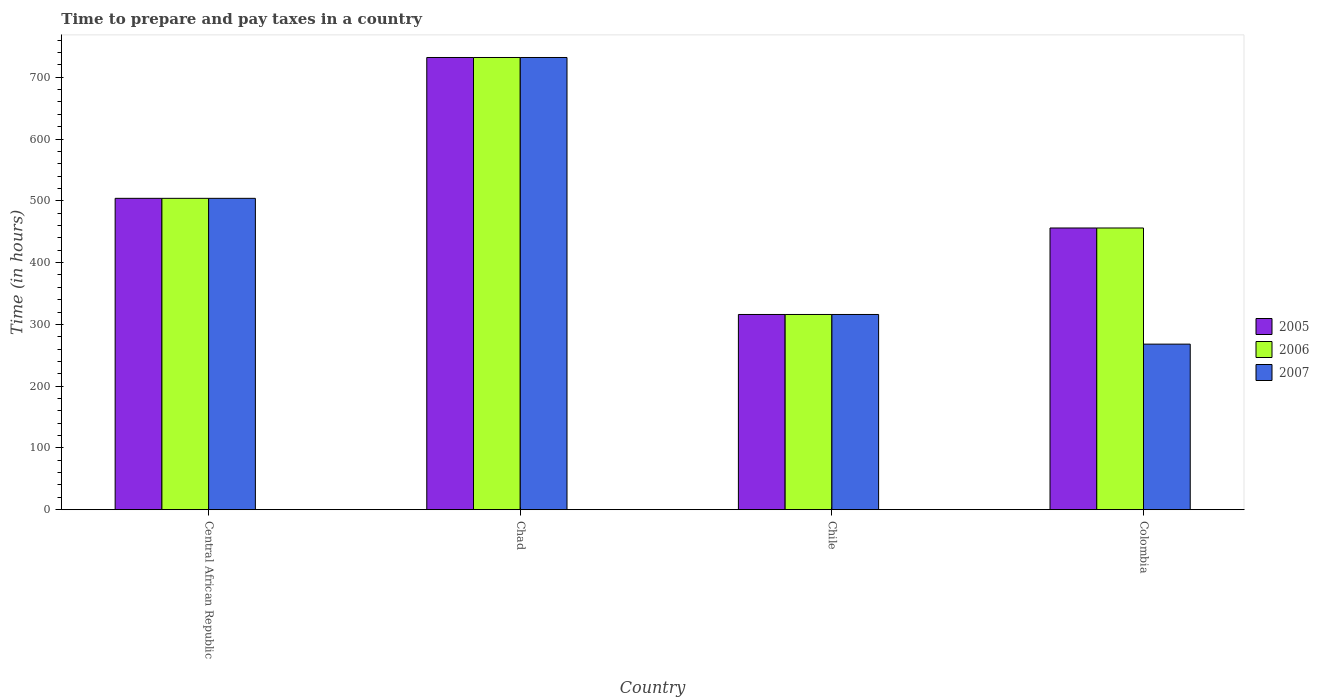How many bars are there on the 1st tick from the left?
Ensure brevity in your answer.  3. What is the label of the 1st group of bars from the left?
Your answer should be very brief. Central African Republic. What is the number of hours required to prepare and pay taxes in 2005 in Chad?
Provide a short and direct response. 732. Across all countries, what is the maximum number of hours required to prepare and pay taxes in 2006?
Your response must be concise. 732. Across all countries, what is the minimum number of hours required to prepare and pay taxes in 2005?
Offer a very short reply. 316. In which country was the number of hours required to prepare and pay taxes in 2005 maximum?
Your answer should be compact. Chad. In which country was the number of hours required to prepare and pay taxes in 2007 minimum?
Offer a terse response. Colombia. What is the total number of hours required to prepare and pay taxes in 2007 in the graph?
Keep it short and to the point. 1820. What is the difference between the number of hours required to prepare and pay taxes in 2006 in Central African Republic and that in Chad?
Keep it short and to the point. -228. What is the difference between the number of hours required to prepare and pay taxes in 2006 in Chile and the number of hours required to prepare and pay taxes in 2005 in Central African Republic?
Keep it short and to the point. -188. What is the average number of hours required to prepare and pay taxes in 2005 per country?
Keep it short and to the point. 502. What is the difference between the number of hours required to prepare and pay taxes of/in 2006 and number of hours required to prepare and pay taxes of/in 2007 in Central African Republic?
Your answer should be compact. 0. What is the ratio of the number of hours required to prepare and pay taxes in 2006 in Chad to that in Colombia?
Your answer should be compact. 1.61. Is the number of hours required to prepare and pay taxes in 2005 in Chile less than that in Colombia?
Ensure brevity in your answer.  Yes. What is the difference between the highest and the second highest number of hours required to prepare and pay taxes in 2007?
Your answer should be very brief. -228. What is the difference between the highest and the lowest number of hours required to prepare and pay taxes in 2005?
Make the answer very short. 416. Is the sum of the number of hours required to prepare and pay taxes in 2006 in Central African Republic and Chile greater than the maximum number of hours required to prepare and pay taxes in 2007 across all countries?
Your response must be concise. Yes. What does the 3rd bar from the left in Chad represents?
Your response must be concise. 2007. How many bars are there?
Ensure brevity in your answer.  12. Does the graph contain any zero values?
Offer a terse response. No. Does the graph contain grids?
Offer a terse response. No. How many legend labels are there?
Give a very brief answer. 3. How are the legend labels stacked?
Provide a succinct answer. Vertical. What is the title of the graph?
Your answer should be compact. Time to prepare and pay taxes in a country. What is the label or title of the X-axis?
Offer a terse response. Country. What is the label or title of the Y-axis?
Keep it short and to the point. Time (in hours). What is the Time (in hours) in 2005 in Central African Republic?
Keep it short and to the point. 504. What is the Time (in hours) of 2006 in Central African Republic?
Keep it short and to the point. 504. What is the Time (in hours) in 2007 in Central African Republic?
Your response must be concise. 504. What is the Time (in hours) of 2005 in Chad?
Your answer should be very brief. 732. What is the Time (in hours) of 2006 in Chad?
Your answer should be very brief. 732. What is the Time (in hours) in 2007 in Chad?
Your answer should be compact. 732. What is the Time (in hours) of 2005 in Chile?
Keep it short and to the point. 316. What is the Time (in hours) in 2006 in Chile?
Your answer should be very brief. 316. What is the Time (in hours) of 2007 in Chile?
Keep it short and to the point. 316. What is the Time (in hours) of 2005 in Colombia?
Keep it short and to the point. 456. What is the Time (in hours) in 2006 in Colombia?
Your answer should be compact. 456. What is the Time (in hours) in 2007 in Colombia?
Provide a succinct answer. 268. Across all countries, what is the maximum Time (in hours) of 2005?
Your answer should be compact. 732. Across all countries, what is the maximum Time (in hours) of 2006?
Your answer should be very brief. 732. Across all countries, what is the maximum Time (in hours) of 2007?
Your answer should be very brief. 732. Across all countries, what is the minimum Time (in hours) in 2005?
Keep it short and to the point. 316. Across all countries, what is the minimum Time (in hours) of 2006?
Keep it short and to the point. 316. Across all countries, what is the minimum Time (in hours) in 2007?
Provide a short and direct response. 268. What is the total Time (in hours) of 2005 in the graph?
Ensure brevity in your answer.  2008. What is the total Time (in hours) in 2006 in the graph?
Offer a terse response. 2008. What is the total Time (in hours) in 2007 in the graph?
Your answer should be very brief. 1820. What is the difference between the Time (in hours) of 2005 in Central African Republic and that in Chad?
Offer a very short reply. -228. What is the difference between the Time (in hours) in 2006 in Central African Republic and that in Chad?
Keep it short and to the point. -228. What is the difference between the Time (in hours) in 2007 in Central African Republic and that in Chad?
Your answer should be very brief. -228. What is the difference between the Time (in hours) of 2005 in Central African Republic and that in Chile?
Your answer should be very brief. 188. What is the difference between the Time (in hours) of 2006 in Central African Republic and that in Chile?
Offer a very short reply. 188. What is the difference between the Time (in hours) in 2007 in Central African Republic and that in Chile?
Give a very brief answer. 188. What is the difference between the Time (in hours) of 2005 in Central African Republic and that in Colombia?
Ensure brevity in your answer.  48. What is the difference between the Time (in hours) in 2006 in Central African Republic and that in Colombia?
Keep it short and to the point. 48. What is the difference between the Time (in hours) of 2007 in Central African Republic and that in Colombia?
Make the answer very short. 236. What is the difference between the Time (in hours) of 2005 in Chad and that in Chile?
Make the answer very short. 416. What is the difference between the Time (in hours) in 2006 in Chad and that in Chile?
Keep it short and to the point. 416. What is the difference between the Time (in hours) in 2007 in Chad and that in Chile?
Your answer should be compact. 416. What is the difference between the Time (in hours) in 2005 in Chad and that in Colombia?
Keep it short and to the point. 276. What is the difference between the Time (in hours) in 2006 in Chad and that in Colombia?
Offer a terse response. 276. What is the difference between the Time (in hours) in 2007 in Chad and that in Colombia?
Keep it short and to the point. 464. What is the difference between the Time (in hours) of 2005 in Chile and that in Colombia?
Make the answer very short. -140. What is the difference between the Time (in hours) of 2006 in Chile and that in Colombia?
Provide a short and direct response. -140. What is the difference between the Time (in hours) in 2005 in Central African Republic and the Time (in hours) in 2006 in Chad?
Your answer should be compact. -228. What is the difference between the Time (in hours) of 2005 in Central African Republic and the Time (in hours) of 2007 in Chad?
Keep it short and to the point. -228. What is the difference between the Time (in hours) of 2006 in Central African Republic and the Time (in hours) of 2007 in Chad?
Offer a terse response. -228. What is the difference between the Time (in hours) of 2005 in Central African Republic and the Time (in hours) of 2006 in Chile?
Offer a terse response. 188. What is the difference between the Time (in hours) in 2005 in Central African Republic and the Time (in hours) in 2007 in Chile?
Your answer should be compact. 188. What is the difference between the Time (in hours) in 2006 in Central African Republic and the Time (in hours) in 2007 in Chile?
Make the answer very short. 188. What is the difference between the Time (in hours) in 2005 in Central African Republic and the Time (in hours) in 2006 in Colombia?
Keep it short and to the point. 48. What is the difference between the Time (in hours) in 2005 in Central African Republic and the Time (in hours) in 2007 in Colombia?
Your answer should be very brief. 236. What is the difference between the Time (in hours) in 2006 in Central African Republic and the Time (in hours) in 2007 in Colombia?
Ensure brevity in your answer.  236. What is the difference between the Time (in hours) of 2005 in Chad and the Time (in hours) of 2006 in Chile?
Offer a terse response. 416. What is the difference between the Time (in hours) of 2005 in Chad and the Time (in hours) of 2007 in Chile?
Provide a succinct answer. 416. What is the difference between the Time (in hours) in 2006 in Chad and the Time (in hours) in 2007 in Chile?
Provide a succinct answer. 416. What is the difference between the Time (in hours) of 2005 in Chad and the Time (in hours) of 2006 in Colombia?
Provide a succinct answer. 276. What is the difference between the Time (in hours) of 2005 in Chad and the Time (in hours) of 2007 in Colombia?
Provide a succinct answer. 464. What is the difference between the Time (in hours) of 2006 in Chad and the Time (in hours) of 2007 in Colombia?
Provide a succinct answer. 464. What is the difference between the Time (in hours) of 2005 in Chile and the Time (in hours) of 2006 in Colombia?
Your answer should be compact. -140. What is the difference between the Time (in hours) of 2005 in Chile and the Time (in hours) of 2007 in Colombia?
Your answer should be very brief. 48. What is the difference between the Time (in hours) of 2006 in Chile and the Time (in hours) of 2007 in Colombia?
Keep it short and to the point. 48. What is the average Time (in hours) of 2005 per country?
Give a very brief answer. 502. What is the average Time (in hours) of 2006 per country?
Make the answer very short. 502. What is the average Time (in hours) of 2007 per country?
Give a very brief answer. 455. What is the difference between the Time (in hours) of 2005 and Time (in hours) of 2006 in Chad?
Ensure brevity in your answer.  0. What is the difference between the Time (in hours) in 2006 and Time (in hours) in 2007 in Chad?
Your answer should be compact. 0. What is the difference between the Time (in hours) in 2005 and Time (in hours) in 2006 in Chile?
Keep it short and to the point. 0. What is the difference between the Time (in hours) of 2005 and Time (in hours) of 2007 in Colombia?
Give a very brief answer. 188. What is the difference between the Time (in hours) in 2006 and Time (in hours) in 2007 in Colombia?
Your answer should be compact. 188. What is the ratio of the Time (in hours) of 2005 in Central African Republic to that in Chad?
Make the answer very short. 0.69. What is the ratio of the Time (in hours) of 2006 in Central African Republic to that in Chad?
Keep it short and to the point. 0.69. What is the ratio of the Time (in hours) of 2007 in Central African Republic to that in Chad?
Give a very brief answer. 0.69. What is the ratio of the Time (in hours) in 2005 in Central African Republic to that in Chile?
Provide a succinct answer. 1.59. What is the ratio of the Time (in hours) of 2006 in Central African Republic to that in Chile?
Your answer should be compact. 1.59. What is the ratio of the Time (in hours) of 2007 in Central African Republic to that in Chile?
Your answer should be compact. 1.59. What is the ratio of the Time (in hours) in 2005 in Central African Republic to that in Colombia?
Ensure brevity in your answer.  1.11. What is the ratio of the Time (in hours) of 2006 in Central African Republic to that in Colombia?
Offer a terse response. 1.11. What is the ratio of the Time (in hours) in 2007 in Central African Republic to that in Colombia?
Your answer should be very brief. 1.88. What is the ratio of the Time (in hours) of 2005 in Chad to that in Chile?
Your response must be concise. 2.32. What is the ratio of the Time (in hours) in 2006 in Chad to that in Chile?
Keep it short and to the point. 2.32. What is the ratio of the Time (in hours) in 2007 in Chad to that in Chile?
Your answer should be very brief. 2.32. What is the ratio of the Time (in hours) in 2005 in Chad to that in Colombia?
Offer a terse response. 1.61. What is the ratio of the Time (in hours) in 2006 in Chad to that in Colombia?
Your answer should be compact. 1.61. What is the ratio of the Time (in hours) in 2007 in Chad to that in Colombia?
Provide a short and direct response. 2.73. What is the ratio of the Time (in hours) of 2005 in Chile to that in Colombia?
Make the answer very short. 0.69. What is the ratio of the Time (in hours) in 2006 in Chile to that in Colombia?
Make the answer very short. 0.69. What is the ratio of the Time (in hours) of 2007 in Chile to that in Colombia?
Your answer should be very brief. 1.18. What is the difference between the highest and the second highest Time (in hours) of 2005?
Offer a terse response. 228. What is the difference between the highest and the second highest Time (in hours) of 2006?
Ensure brevity in your answer.  228. What is the difference between the highest and the second highest Time (in hours) in 2007?
Provide a succinct answer. 228. What is the difference between the highest and the lowest Time (in hours) in 2005?
Your answer should be very brief. 416. What is the difference between the highest and the lowest Time (in hours) in 2006?
Ensure brevity in your answer.  416. What is the difference between the highest and the lowest Time (in hours) of 2007?
Make the answer very short. 464. 